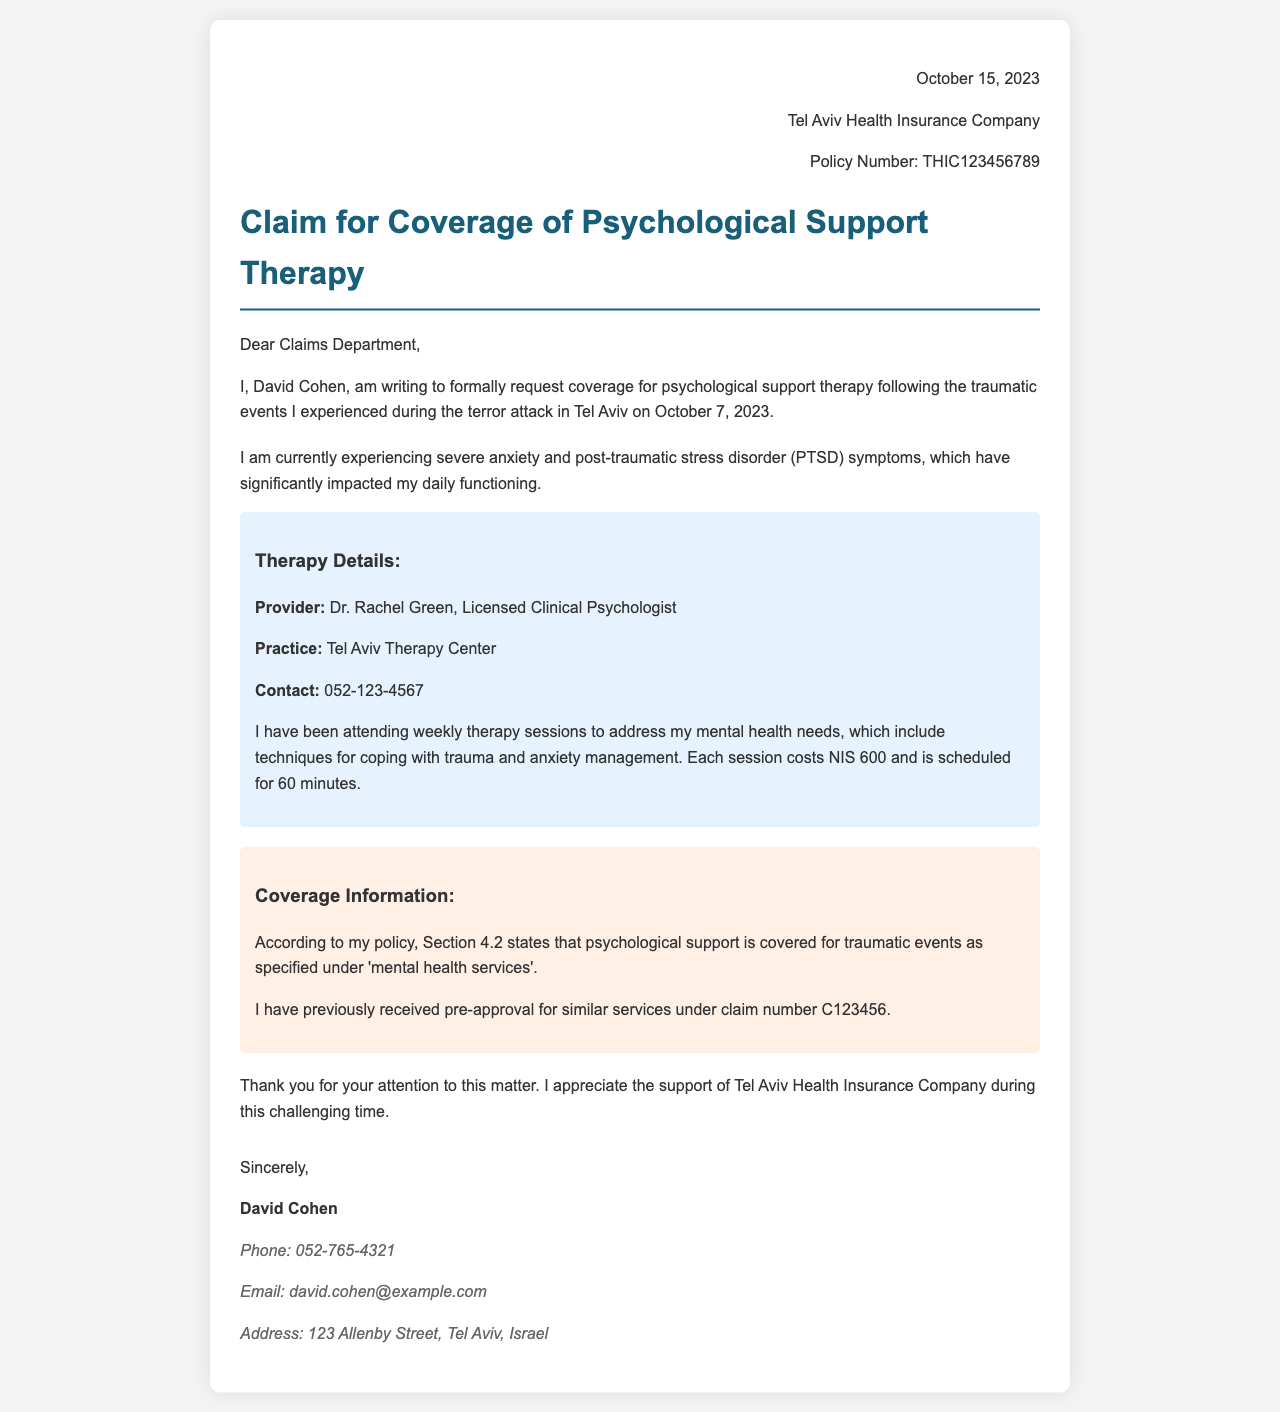What is the date of the letter? The letter is dated October 15, 2023.
Answer: October 15, 2023 Who is the therapist mentioned in the letter? The letter states that the therapist is Dr. Rachel Green.
Answer: Dr. Rachel Green What is the cost of each therapy session? The document mentions that each session costs NIS 600.
Answer: NIS 600 What is the name of the insurance company? The letter is addressed to Tel Aviv Health Insurance Company.
Answer: Tel Aviv Health Insurance Company What symptoms is the claimant experiencing? The letter states that the claimant is experiencing severe anxiety and post-traumatic stress disorder (PTSD) symptoms.
Answer: Severe anxiety and PTSD Which section of the policy covers psychological support? The section mentioned in the letter is Section 4.2.
Answer: Section 4.2 What is the contact number for the therapy provider? The document provides the contact number as 052-123-4567.
Answer: 052-123-4567 What was the previous claim number for similar services? The letter states the previous claim number is C123456.
Answer: C123456 How often are the therapy sessions scheduled? The document indicates that therapy sessions are scheduled weekly.
Answer: Weekly 